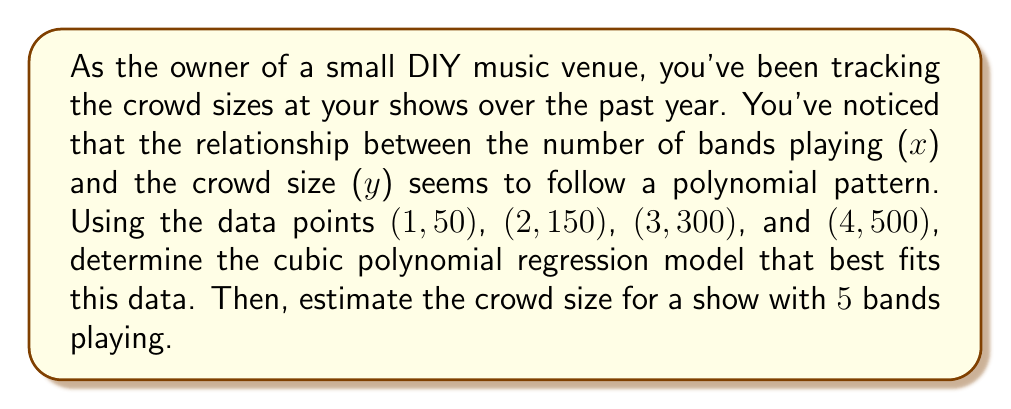What is the answer to this math problem? To solve this problem, we'll use cubic polynomial regression to find a model of the form $y = ax^3 + bx^2 + cx + d$ that best fits the given data points.

1. Set up the system of equations:
   For each data point (x, y), we have:
   $ax^3 + bx^2 + cx + d = y$

   This gives us four equations:
   $a(1)^3 + b(1)^2 + c(1) + d = 50$
   $a(2)^3 + b(2)^2 + c(2) + d = 150$
   $a(3)^3 + b(3)^2 + c(3) + d = 300$
   $a(4)^3 + b(4)^2 + c(4) + d = 500$

2. Simplify the equations:
   $a + b + c + d = 50$
   $8a + 4b + 2c + d = 150$
   $27a + 9b + 3c + d = 300$
   $64a + 16b + 4c + d = 500$

3. Solve the system of equations:
   Using elimination or matrix methods, we find:
   $a = 10$
   $b = -35$
   $c = 85$
   $d = -10$

4. Write the cubic polynomial regression model:
   $y = 10x^3 - 35x^2 + 85x - 10$

5. Estimate the crowd size for a show with 5 bands:
   Substitute $x = 5$ into the model:
   $y = 10(5)^3 - 35(5)^2 + 85(5) - 10$
   $y = 10(125) - 35(25) + 85(5) - 10$
   $y = 1250 - 875 + 425 - 10$
   $y = 790$

Therefore, the estimated crowd size for a show with 5 bands playing is 790 people.
Answer: The cubic polynomial regression model is $y = 10x^3 - 35x^2 + 85x - 10$, and the estimated crowd size for a show with 5 bands playing is 790 people. 